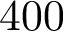<formula> <loc_0><loc_0><loc_500><loc_500>4 0 0</formula> 